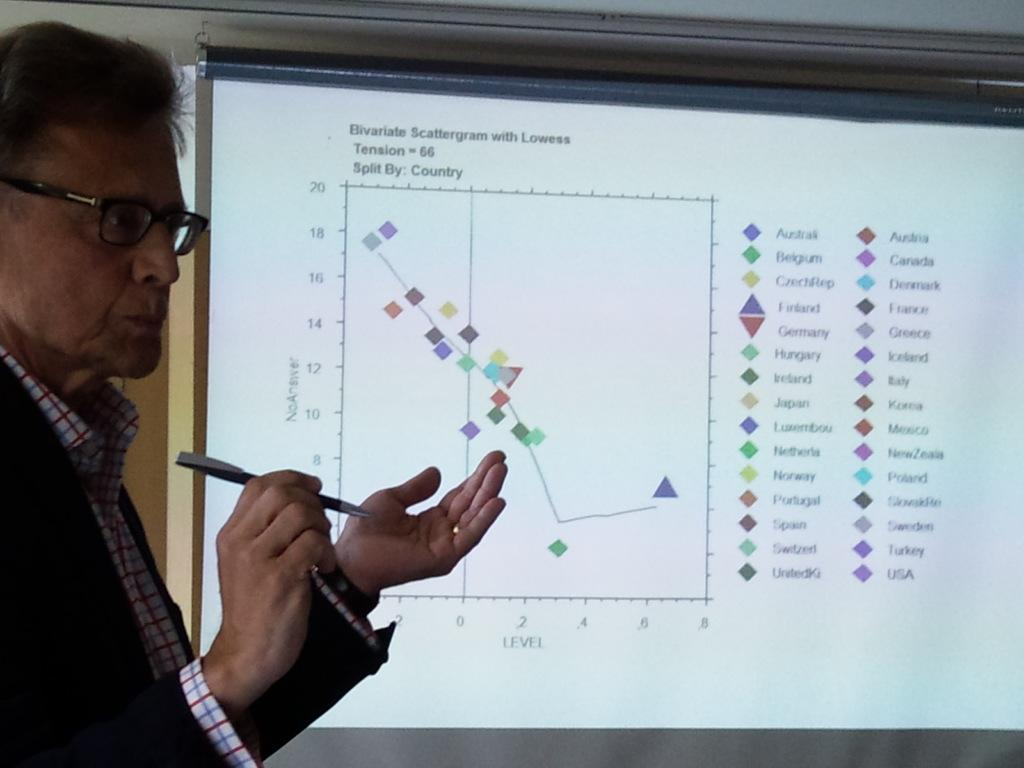Who is present in the image? There is a man in the image. What is the man wearing? The man is wearing a black suit and shirt. What is the man holding in the image? The man is holding a pen. What can be seen on the screen in the image? The facts provided do not specify what is on the screen, so we cannot answer that question definitively. What type of crime is the judge discussing on the canvas in the image? There is no judge, crime, or canvas present in the image. 